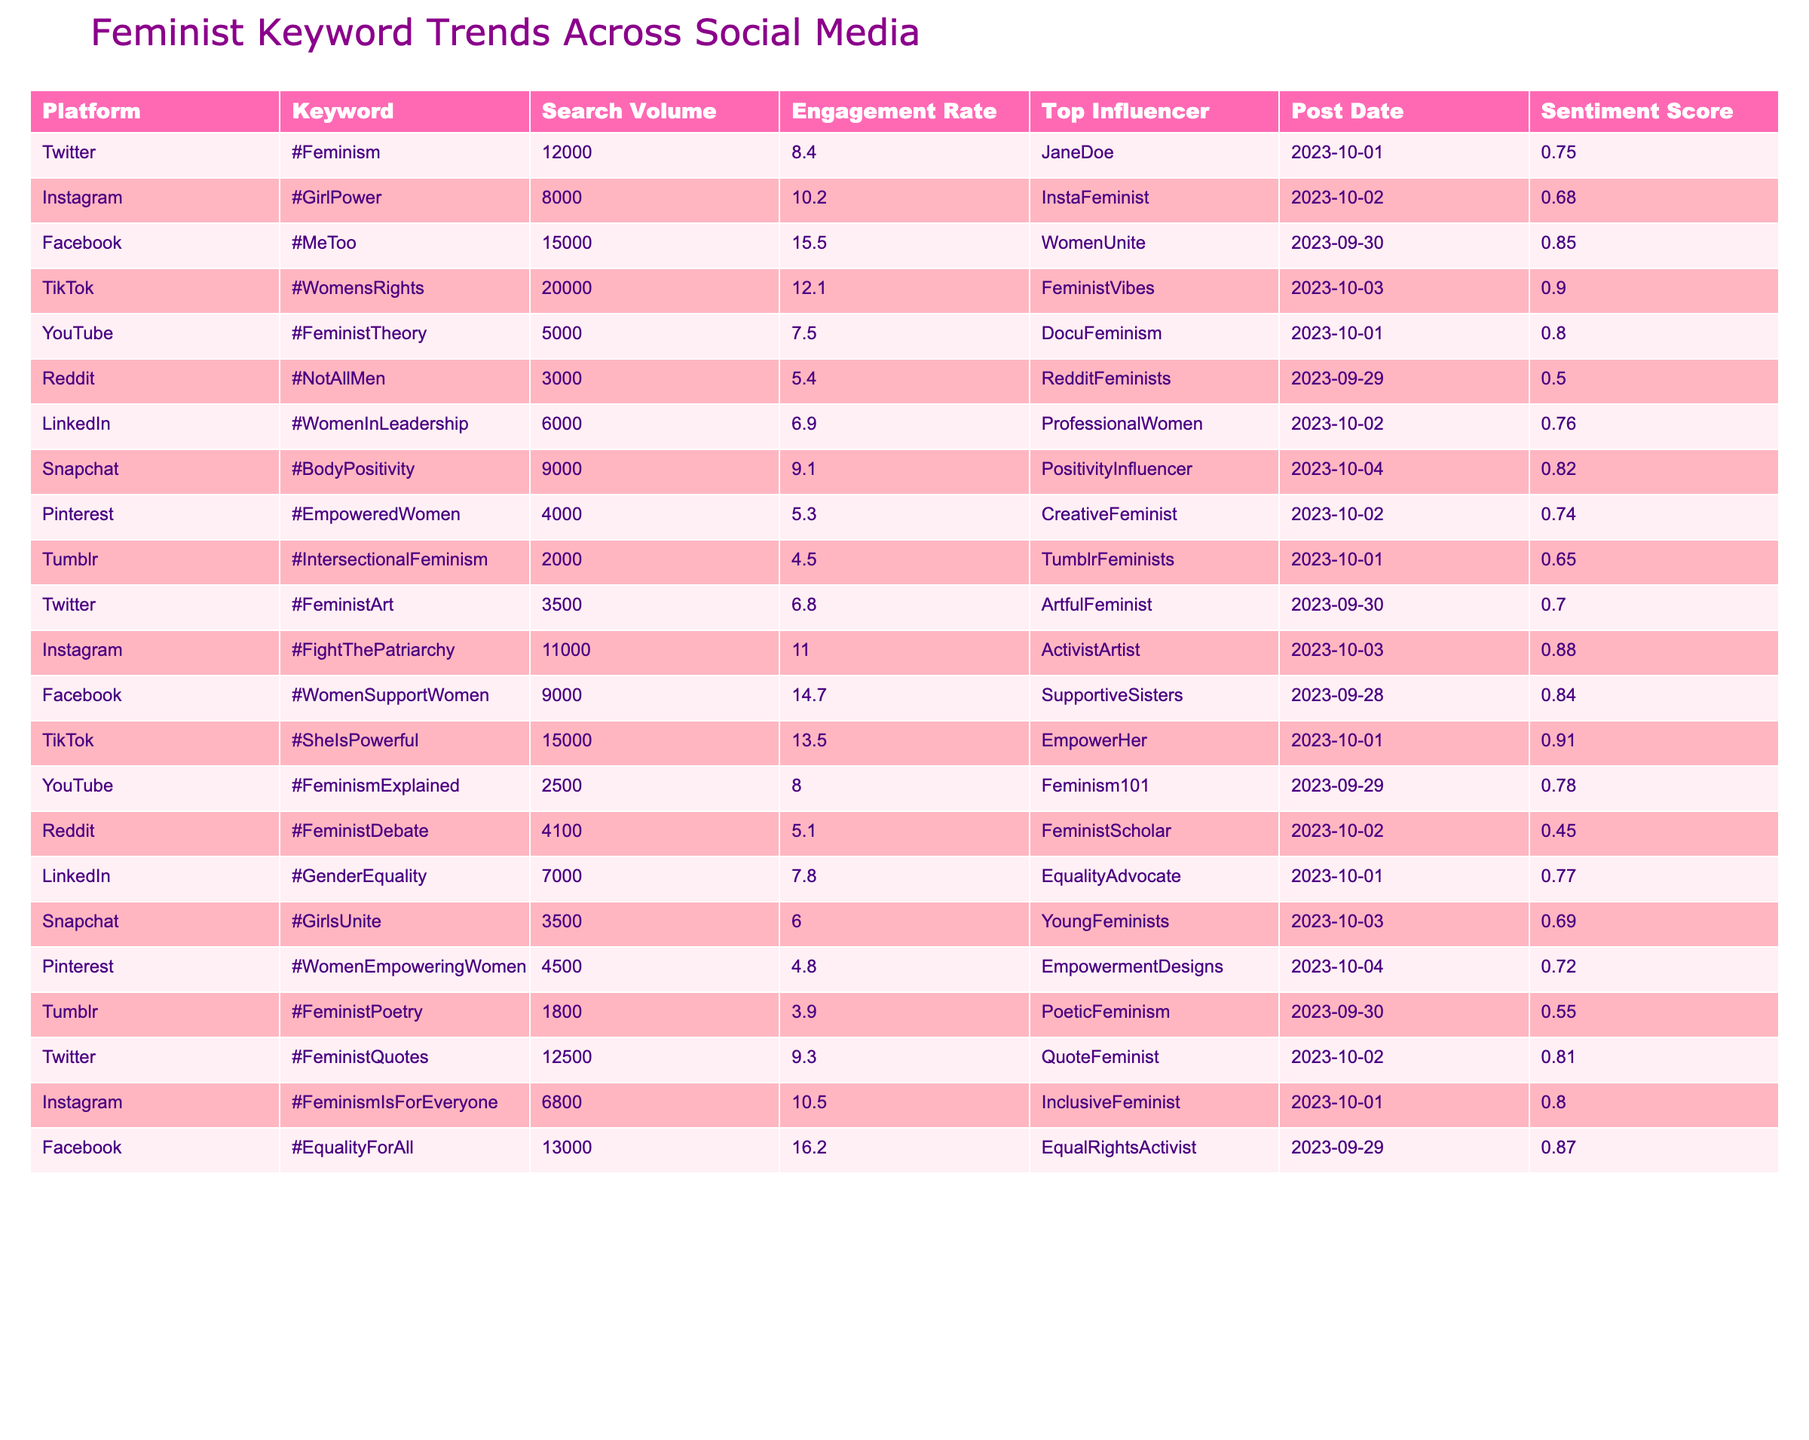What is the keyword with the highest search volume? The table shows that #WomensRights has the highest search volume at 20,000.
Answer: #WomensRights Which platform had the highest engagement rate? The engagement rates are listed for each platform, and #WomenSupportWomen on Facebook has the highest engagement rate of 16.2.
Answer: Facebook How many keywords have a sentiment score above 0.8? By counting the sentiment scores above 0.8, we find that there are 5 keywords: #MeToo, #WomensRights, #SheIsPowerful, #WomenSupportWomen, and #EqualityForAll.
Answer: 5 What is the average search volume for TikTok keywords? The TikTok keywords are #WomensRights and #SheIsPowerful, with search volumes of 20,000 and 15,000 respectively. The average is (20,000 + 15,000) / 2 = 17,500.
Answer: 17,500 Is there a keyword related to leadership on LinkedIn? The table lists #WomenInLeadership as a keyword for LinkedIn.
Answer: Yes Which keyword had the lowest engagement rate and what was it? By looking through the engagement rates, #FeministPoetry on Tumblr has the lowest engagement rate at 3.9.
Answer: #FeministPoetry What is the sentiment score difference between the highest and lowest scoring keywords in the table? The highest sentiment score is 0.91 for #SheIsPowerful and the lowest is 0.45 for #FeministDebate. The difference is 0.91 - 0.45 = 0.46.
Answer: 0.46 Which social media platform has the most keywords listed and what are they? By counting the entries, Twitter has 4 keywords: #Feminism, #FeministArt, #FeministQuotes, and the total count is higher than others.
Answer: Twitter What was the post date for the keyword with the highest search volume? The keyword with the highest search volume, #WomensRights, was posted on 2023-10-03.
Answer: 2023-10-03 Which two keywords have similar search volumes? #GirlsUnite has a search volume of 3,500, and #FeministArt has a search volume of 3,500 as well, making them similar.
Answer: #GirlsUnite and #FeministArt 